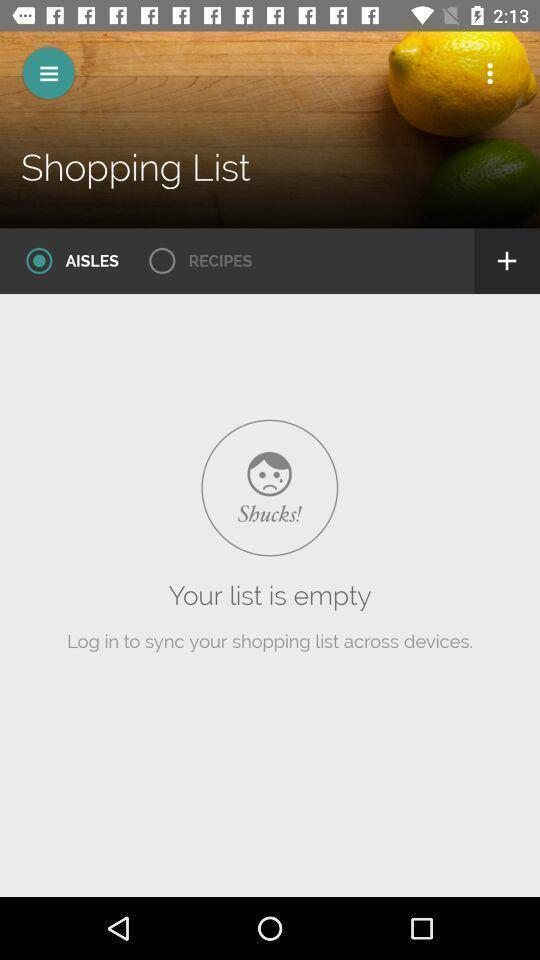Please provide a description for this image. Page of a shopping application. 